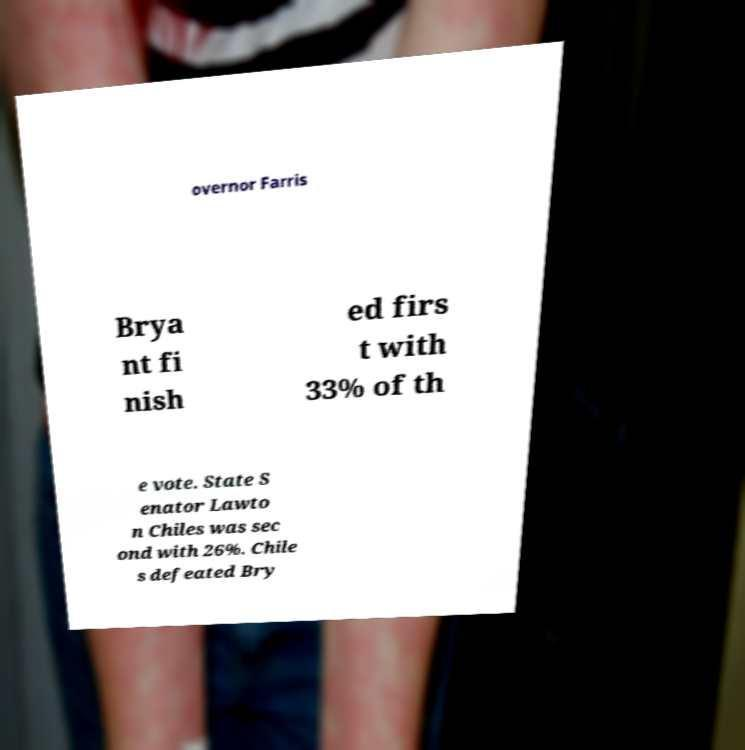Please read and relay the text visible in this image. What does it say? overnor Farris Brya nt fi nish ed firs t with 33% of th e vote. State S enator Lawto n Chiles was sec ond with 26%. Chile s defeated Bry 